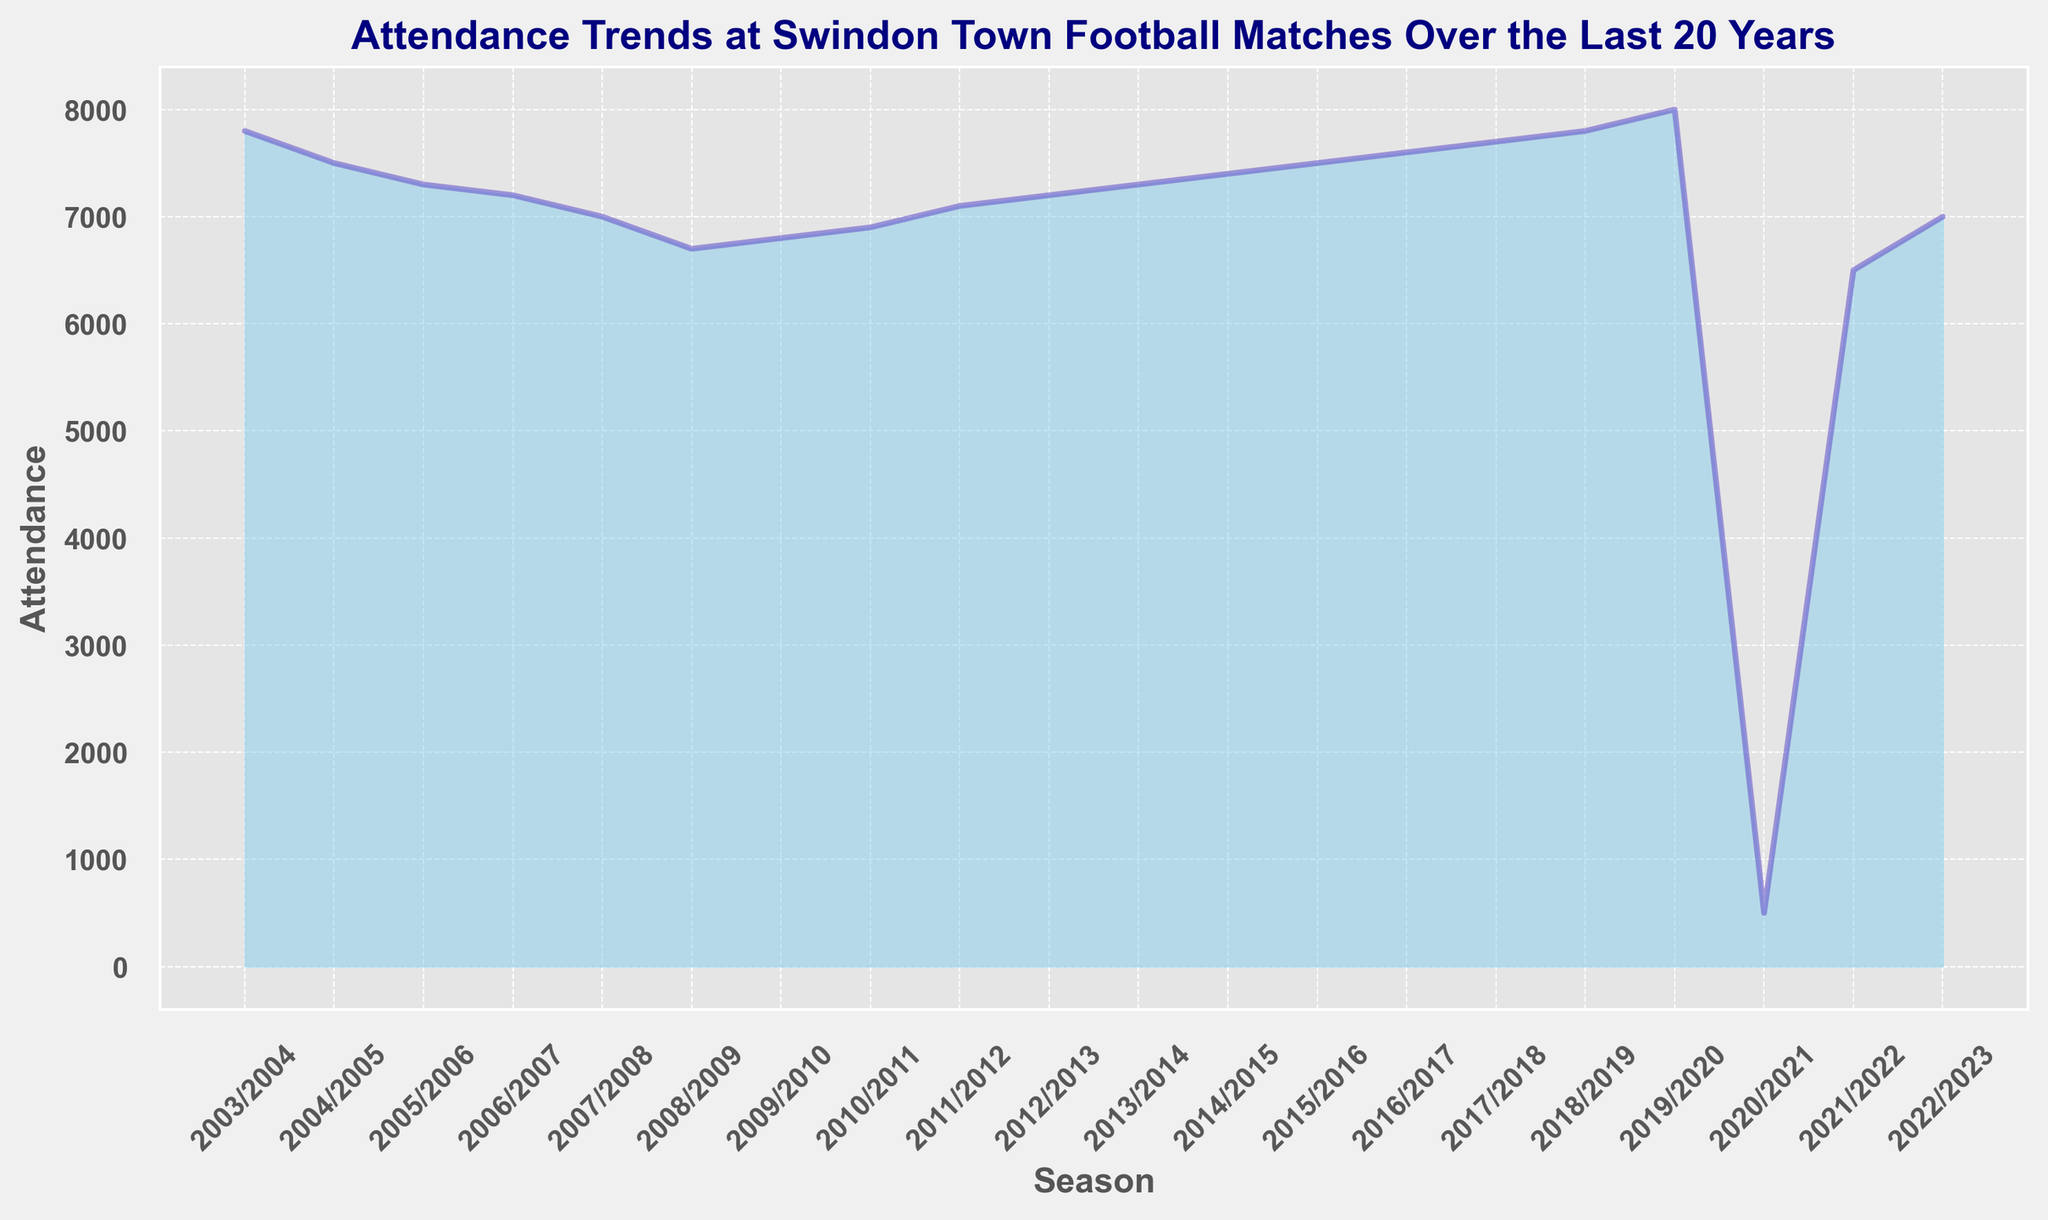What's the highest attendance recorded in the last 20 years? By looking at the peaks in the filled area chart, we can identify the highest point on the y-axis corresponding to attendance. The highest attendance is during the 2019/2020 season with 8000 attendees.
Answer: 8000 How did the attendance in the 2020/2021 season compare to the previous season? The 2020/2021 season shows a significant drop in attendance compared to the 2019/2020 season. The attendance fell from 8000 to 500.
Answer: It decreased significantly What is the average attendance over the last 20 years? To find the average attendance, sum up all the attendance figures and divide by the number of seasons. The total attendance is 132600, and there are 20 seasons. Therefore, the average is 132600/20 = 6630.
Answer: 6630 Which seasons show an increase in attendance from the previous season? By observing the slopes of the area chart, we can identify the seasons where the line slopes upwards. The seasons that show increases are 2011/2012, 2012/2013, 2014/2015, 2015/2016, 2016/2017, 2017/2018, 2018/2019, and 2019/2020.
Answer: Several seasons, including 2011/2012, 2012/2013, 2014/2015, 2015/2016, 2016/2017, 2017/2018, 2018/2019, 2019/2020 What was the attendance trend between the 2008/2009 and 2010/2011 seasons? By looking at the filled area between these years, we can observe an increasing trend. Attendance went from 6700 in 2008/2009 to 6900 in 2010/2011.
Answer: Increasing trend What was the difference in attendance between the highest and lowest seasons? The highest attendance is 8000 (2019/2020 season), and the lowest is 500 (2020/2021 season). The difference is 8000 - 500 = 7500.
Answer: 7500 During which seasons did the attendance dip below 7000? By identifying the portions of the chart that fall below the y-axis value of 7000, we find that the seasons 2009/2010, 2008/2009, 2007/2008, 2006/2007, 2005/2006, 2004/2005, 2003/2004, 2020/2021 and 2021/2022 had attendances below 7000.
Answer: Several seasons, including but not limited to 2003/2004, 2004/2005, 2020/2021, and 2021/2022 Between which consecutive seasons was the greatest increase in attendance observed? By examining the year-to-year increases, the most considerable jump occurred between the 2021/2022 and 2022/2023 seasons, where the attendance increased from 6500 to 7000.
Answer: 2021/2022 to 2022/2023 